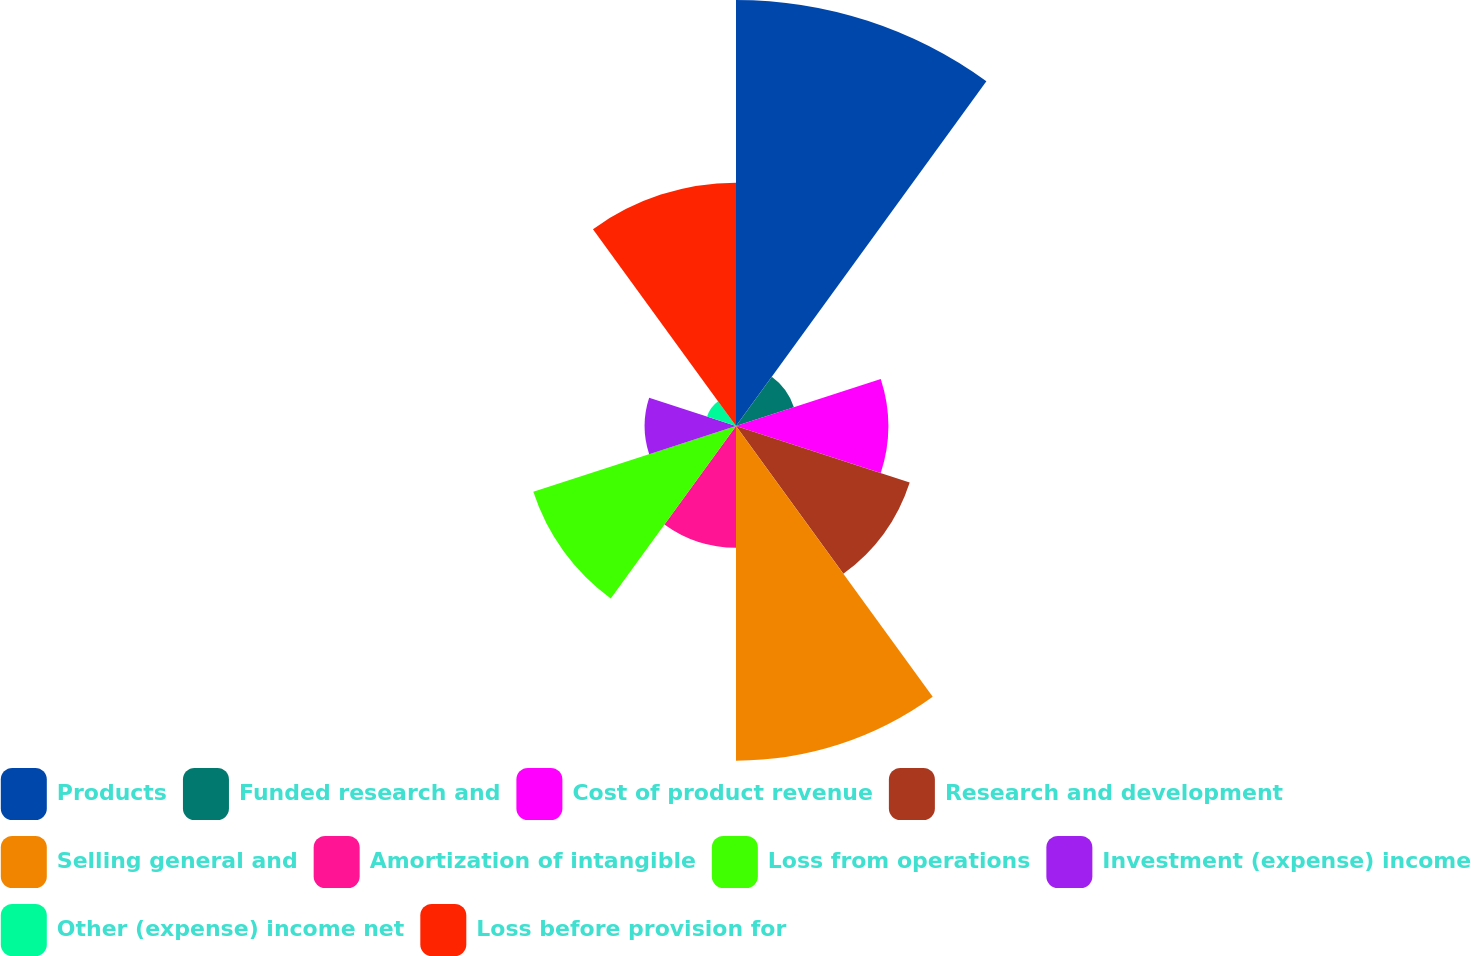<chart> <loc_0><loc_0><loc_500><loc_500><pie_chart><fcel>Products<fcel>Funded research and<fcel>Cost of product revenue<fcel>Research and development<fcel>Selling general and<fcel>Amortization of intangible<fcel>Loss from operations<fcel>Investment (expense) income<fcel>Other (expense) income net<fcel>Loss before provision for<nl><fcel>22.95%<fcel>3.28%<fcel>8.2%<fcel>9.84%<fcel>18.03%<fcel>6.56%<fcel>11.48%<fcel>4.92%<fcel>1.64%<fcel>13.11%<nl></chart> 